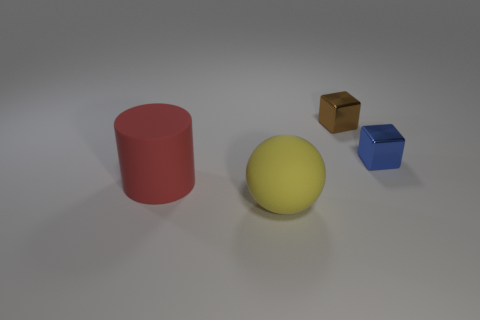Add 1 large yellow things. How many objects exist? 5 Subtract all balls. How many objects are left? 3 Add 4 metal blocks. How many metal blocks are left? 6 Add 1 big rubber spheres. How many big rubber spheres exist? 2 Subtract 1 yellow balls. How many objects are left? 3 Subtract all big brown shiny objects. Subtract all brown cubes. How many objects are left? 3 